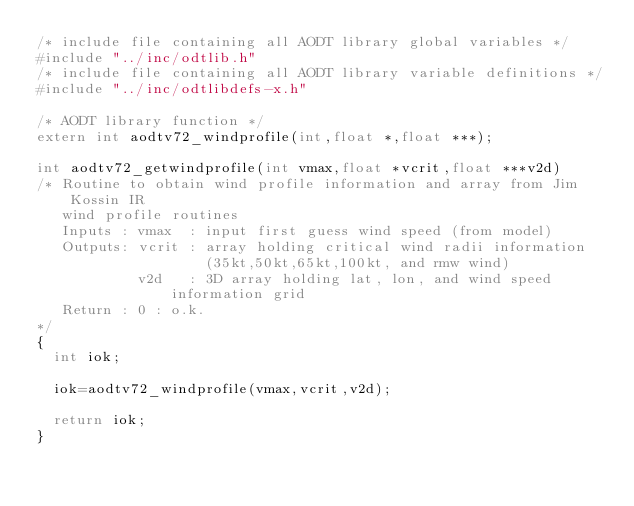Convert code to text. <code><loc_0><loc_0><loc_500><loc_500><_C_>/* include file containing all AODT library global variables */
#include "../inc/odtlib.h"
/* include file containing all AODT library variable definitions */
#include "../inc/odtlibdefs-x.h"

/* AODT library function */
extern int aodtv72_windprofile(int,float *,float ***);

int aodtv72_getwindprofile(int vmax,float *vcrit,float ***v2d)
/* Routine to obtain wind profile information and array from Jim Kossin IR 
   wind profile routines
   Inputs : vmax  : input first guess wind speed (from model)
   Outputs: vcrit : array holding critical wind radii information
                    (35kt,50kt,65kt,100kt, and rmw wind)
            v2d   : 3D array holding lat, lon, and wind speed information grid
   Return : 0 : o.k.
*/
{
  int iok;

  iok=aodtv72_windprofile(vmax,vcrit,v2d);

  return iok;
}
</code> 